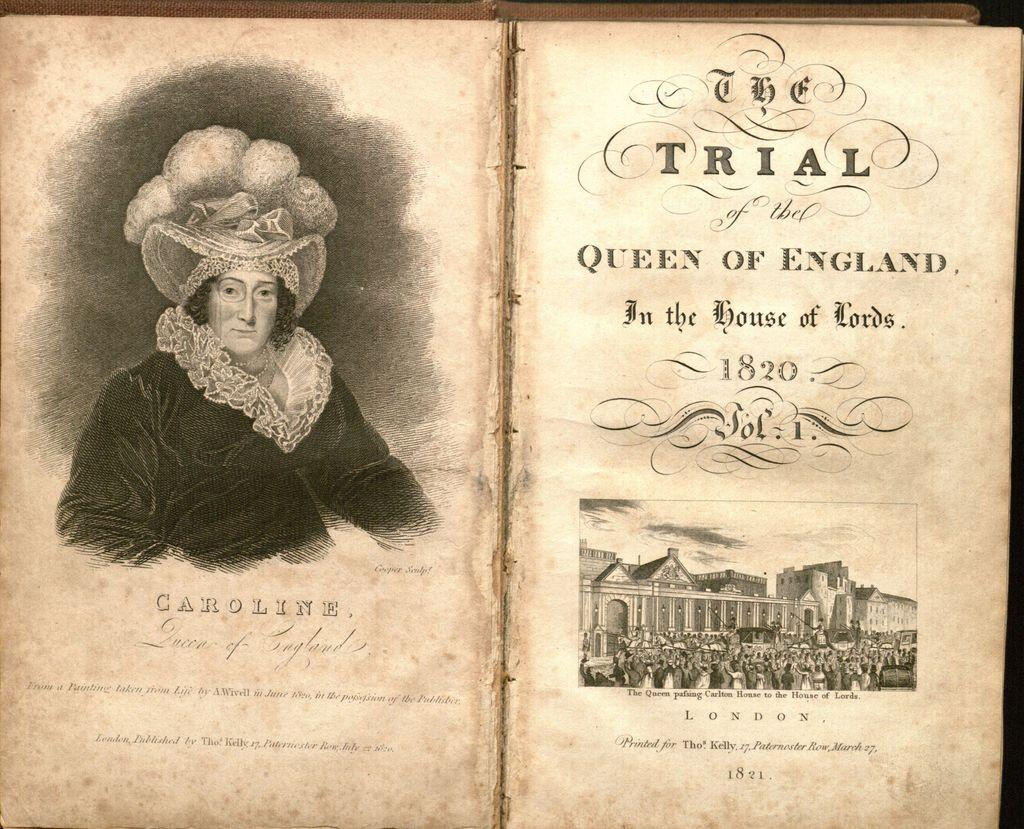<image>
Summarize the visual content of the image. An open old book titled The Trial of the Queen of England in the House of Lords 1820. 